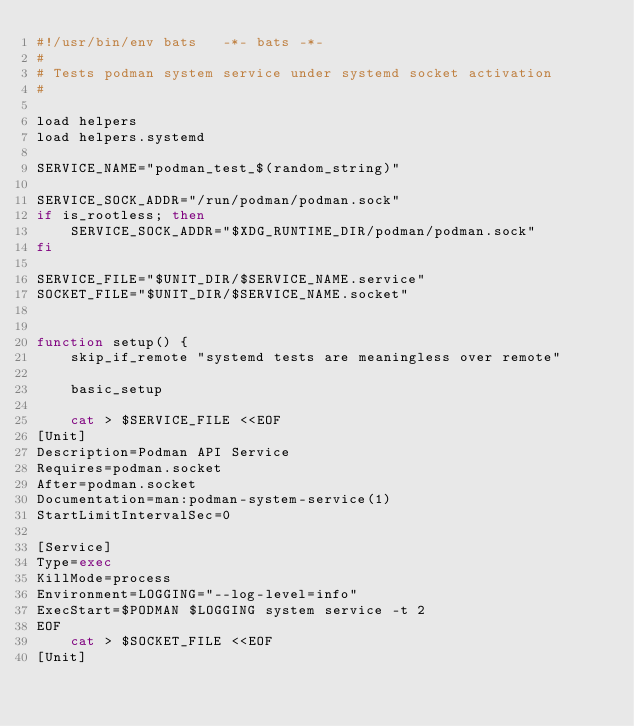Convert code to text. <code><loc_0><loc_0><loc_500><loc_500><_Bash_>#!/usr/bin/env bats   -*- bats -*-
#
# Tests podman system service under systemd socket activation
#

load helpers
load helpers.systemd

SERVICE_NAME="podman_test_$(random_string)"

SERVICE_SOCK_ADDR="/run/podman/podman.sock"
if is_rootless; then
    SERVICE_SOCK_ADDR="$XDG_RUNTIME_DIR/podman/podman.sock"
fi

SERVICE_FILE="$UNIT_DIR/$SERVICE_NAME.service"
SOCKET_FILE="$UNIT_DIR/$SERVICE_NAME.socket"


function setup() {
    skip_if_remote "systemd tests are meaningless over remote"

    basic_setup

    cat > $SERVICE_FILE <<EOF
[Unit]
Description=Podman API Service
Requires=podman.socket
After=podman.socket
Documentation=man:podman-system-service(1)
StartLimitIntervalSec=0

[Service]
Type=exec
KillMode=process
Environment=LOGGING="--log-level=info"
ExecStart=$PODMAN $LOGGING system service -t 2
EOF
    cat > $SOCKET_FILE <<EOF
[Unit]</code> 